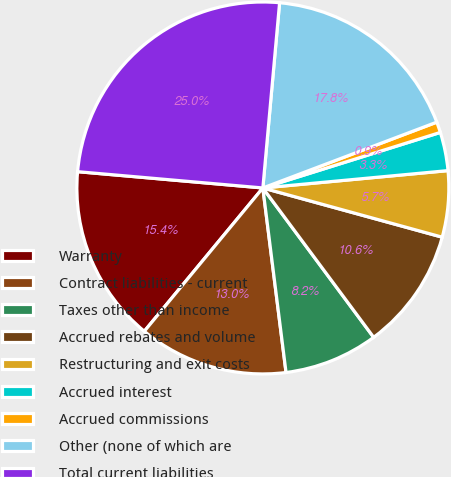Convert chart to OTSL. <chart><loc_0><loc_0><loc_500><loc_500><pie_chart><fcel>Warranty<fcel>Contract liabilities - current<fcel>Taxes other than income<fcel>Accrued rebates and volume<fcel>Restructuring and exit costs<fcel>Accrued interest<fcel>Accrued commissions<fcel>Other (none of which are<fcel>Total current liabilities<nl><fcel>15.4%<fcel>12.99%<fcel>8.17%<fcel>10.58%<fcel>5.75%<fcel>3.34%<fcel>0.93%<fcel>17.81%<fcel>25.04%<nl></chart> 